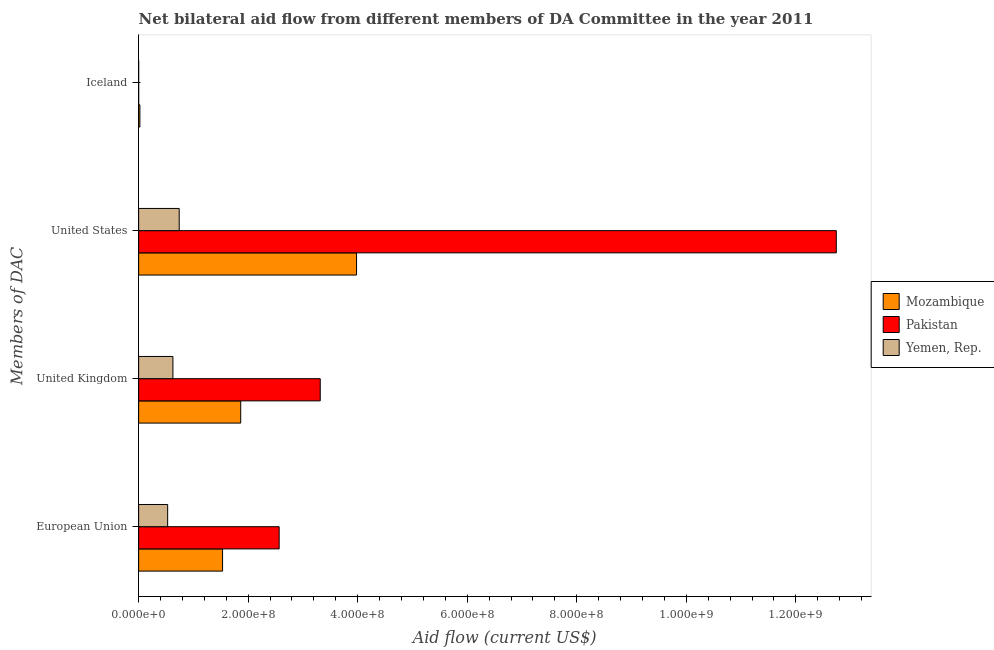Are the number of bars per tick equal to the number of legend labels?
Provide a succinct answer. Yes. What is the label of the 3rd group of bars from the top?
Offer a very short reply. United Kingdom. What is the amount of aid given by eu in Mozambique?
Your answer should be very brief. 1.53e+08. Across all countries, what is the maximum amount of aid given by us?
Offer a very short reply. 1.27e+09. Across all countries, what is the minimum amount of aid given by uk?
Make the answer very short. 6.26e+07. In which country was the amount of aid given by eu minimum?
Make the answer very short. Yemen, Rep. What is the total amount of aid given by uk in the graph?
Offer a very short reply. 5.81e+08. What is the difference between the amount of aid given by iceland in Yemen, Rep. and that in Pakistan?
Make the answer very short. -4.00e+04. What is the difference between the amount of aid given by us in Pakistan and the amount of aid given by uk in Yemen, Rep.?
Your response must be concise. 1.21e+09. What is the average amount of aid given by eu per country?
Provide a short and direct response. 1.54e+08. What is the difference between the amount of aid given by us and amount of aid given by iceland in Pakistan?
Your response must be concise. 1.27e+09. What is the ratio of the amount of aid given by uk in Pakistan to that in Mozambique?
Ensure brevity in your answer.  1.78. Is the amount of aid given by us in Yemen, Rep. less than that in Mozambique?
Offer a very short reply. Yes. Is the difference between the amount of aid given by eu in Mozambique and Yemen, Rep. greater than the difference between the amount of aid given by us in Mozambique and Yemen, Rep.?
Make the answer very short. No. What is the difference between the highest and the second highest amount of aid given by eu?
Provide a short and direct response. 1.03e+08. What is the difference between the highest and the lowest amount of aid given by uk?
Make the answer very short. 2.69e+08. Is the sum of the amount of aid given by iceland in Pakistan and Mozambique greater than the maximum amount of aid given by uk across all countries?
Ensure brevity in your answer.  No. Is it the case that in every country, the sum of the amount of aid given by iceland and amount of aid given by us is greater than the sum of amount of aid given by uk and amount of aid given by eu?
Offer a terse response. No. What does the 3rd bar from the top in Iceland represents?
Ensure brevity in your answer.  Mozambique. What does the 3rd bar from the bottom in United Kingdom represents?
Offer a very short reply. Yemen, Rep. Is it the case that in every country, the sum of the amount of aid given by eu and amount of aid given by uk is greater than the amount of aid given by us?
Give a very brief answer. No. Are all the bars in the graph horizontal?
Keep it short and to the point. Yes. How many countries are there in the graph?
Offer a very short reply. 3. What is the difference between two consecutive major ticks on the X-axis?
Your response must be concise. 2.00e+08. Are the values on the major ticks of X-axis written in scientific E-notation?
Your answer should be compact. Yes. Does the graph contain any zero values?
Offer a very short reply. No. Does the graph contain grids?
Make the answer very short. No. Where does the legend appear in the graph?
Give a very brief answer. Center right. How many legend labels are there?
Ensure brevity in your answer.  3. What is the title of the graph?
Provide a short and direct response. Net bilateral aid flow from different members of DA Committee in the year 2011. What is the label or title of the Y-axis?
Ensure brevity in your answer.  Members of DAC. What is the Aid flow (current US$) of Mozambique in European Union?
Your response must be concise. 1.53e+08. What is the Aid flow (current US$) in Pakistan in European Union?
Ensure brevity in your answer.  2.57e+08. What is the Aid flow (current US$) of Yemen, Rep. in European Union?
Your answer should be compact. 5.30e+07. What is the Aid flow (current US$) of Mozambique in United Kingdom?
Ensure brevity in your answer.  1.86e+08. What is the Aid flow (current US$) of Pakistan in United Kingdom?
Provide a succinct answer. 3.32e+08. What is the Aid flow (current US$) in Yemen, Rep. in United Kingdom?
Offer a very short reply. 6.26e+07. What is the Aid flow (current US$) in Mozambique in United States?
Give a very brief answer. 3.98e+08. What is the Aid flow (current US$) of Pakistan in United States?
Provide a short and direct response. 1.27e+09. What is the Aid flow (current US$) of Yemen, Rep. in United States?
Make the answer very short. 7.41e+07. What is the Aid flow (current US$) of Mozambique in Iceland?
Offer a very short reply. 2.29e+06. What is the Aid flow (current US$) in Yemen, Rep. in Iceland?
Make the answer very short. 2.00e+04. Across all Members of DAC, what is the maximum Aid flow (current US$) of Mozambique?
Provide a short and direct response. 3.98e+08. Across all Members of DAC, what is the maximum Aid flow (current US$) in Pakistan?
Offer a very short reply. 1.27e+09. Across all Members of DAC, what is the maximum Aid flow (current US$) of Yemen, Rep.?
Make the answer very short. 7.41e+07. Across all Members of DAC, what is the minimum Aid flow (current US$) in Mozambique?
Give a very brief answer. 2.29e+06. Across all Members of DAC, what is the minimum Aid flow (current US$) of Pakistan?
Your answer should be compact. 6.00e+04. What is the total Aid flow (current US$) of Mozambique in the graph?
Give a very brief answer. 7.40e+08. What is the total Aid flow (current US$) of Pakistan in the graph?
Make the answer very short. 1.86e+09. What is the total Aid flow (current US$) of Yemen, Rep. in the graph?
Make the answer very short. 1.90e+08. What is the difference between the Aid flow (current US$) of Mozambique in European Union and that in United Kingdom?
Give a very brief answer. -3.32e+07. What is the difference between the Aid flow (current US$) of Pakistan in European Union and that in United Kingdom?
Provide a short and direct response. -7.50e+07. What is the difference between the Aid flow (current US$) in Yemen, Rep. in European Union and that in United Kingdom?
Your answer should be very brief. -9.61e+06. What is the difference between the Aid flow (current US$) in Mozambique in European Union and that in United States?
Give a very brief answer. -2.45e+08. What is the difference between the Aid flow (current US$) of Pakistan in European Union and that in United States?
Ensure brevity in your answer.  -1.02e+09. What is the difference between the Aid flow (current US$) of Yemen, Rep. in European Union and that in United States?
Your response must be concise. -2.11e+07. What is the difference between the Aid flow (current US$) of Mozambique in European Union and that in Iceland?
Your answer should be very brief. 1.51e+08. What is the difference between the Aid flow (current US$) in Pakistan in European Union and that in Iceland?
Give a very brief answer. 2.57e+08. What is the difference between the Aid flow (current US$) of Yemen, Rep. in European Union and that in Iceland?
Your answer should be very brief. 5.30e+07. What is the difference between the Aid flow (current US$) in Mozambique in United Kingdom and that in United States?
Your response must be concise. -2.12e+08. What is the difference between the Aid flow (current US$) in Pakistan in United Kingdom and that in United States?
Give a very brief answer. -9.42e+08. What is the difference between the Aid flow (current US$) of Yemen, Rep. in United Kingdom and that in United States?
Give a very brief answer. -1.15e+07. What is the difference between the Aid flow (current US$) in Mozambique in United Kingdom and that in Iceland?
Provide a succinct answer. 1.84e+08. What is the difference between the Aid flow (current US$) of Pakistan in United Kingdom and that in Iceland?
Your answer should be compact. 3.32e+08. What is the difference between the Aid flow (current US$) in Yemen, Rep. in United Kingdom and that in Iceland?
Keep it short and to the point. 6.26e+07. What is the difference between the Aid flow (current US$) in Mozambique in United States and that in Iceland?
Keep it short and to the point. 3.96e+08. What is the difference between the Aid flow (current US$) of Pakistan in United States and that in Iceland?
Offer a very short reply. 1.27e+09. What is the difference between the Aid flow (current US$) in Yemen, Rep. in United States and that in Iceland?
Make the answer very short. 7.41e+07. What is the difference between the Aid flow (current US$) of Mozambique in European Union and the Aid flow (current US$) of Pakistan in United Kingdom?
Keep it short and to the point. -1.78e+08. What is the difference between the Aid flow (current US$) of Mozambique in European Union and the Aid flow (current US$) of Yemen, Rep. in United Kingdom?
Your answer should be very brief. 9.06e+07. What is the difference between the Aid flow (current US$) in Pakistan in European Union and the Aid flow (current US$) in Yemen, Rep. in United Kingdom?
Give a very brief answer. 1.94e+08. What is the difference between the Aid flow (current US$) in Mozambique in European Union and the Aid flow (current US$) in Pakistan in United States?
Provide a succinct answer. -1.12e+09. What is the difference between the Aid flow (current US$) of Mozambique in European Union and the Aid flow (current US$) of Yemen, Rep. in United States?
Provide a short and direct response. 7.92e+07. What is the difference between the Aid flow (current US$) of Pakistan in European Union and the Aid flow (current US$) of Yemen, Rep. in United States?
Ensure brevity in your answer.  1.83e+08. What is the difference between the Aid flow (current US$) in Mozambique in European Union and the Aid flow (current US$) in Pakistan in Iceland?
Offer a terse response. 1.53e+08. What is the difference between the Aid flow (current US$) in Mozambique in European Union and the Aid flow (current US$) in Yemen, Rep. in Iceland?
Ensure brevity in your answer.  1.53e+08. What is the difference between the Aid flow (current US$) in Pakistan in European Union and the Aid flow (current US$) in Yemen, Rep. in Iceland?
Your answer should be very brief. 2.57e+08. What is the difference between the Aid flow (current US$) of Mozambique in United Kingdom and the Aid flow (current US$) of Pakistan in United States?
Give a very brief answer. -1.09e+09. What is the difference between the Aid flow (current US$) in Mozambique in United Kingdom and the Aid flow (current US$) in Yemen, Rep. in United States?
Give a very brief answer. 1.12e+08. What is the difference between the Aid flow (current US$) of Pakistan in United Kingdom and the Aid flow (current US$) of Yemen, Rep. in United States?
Provide a succinct answer. 2.58e+08. What is the difference between the Aid flow (current US$) of Mozambique in United Kingdom and the Aid flow (current US$) of Pakistan in Iceland?
Your answer should be compact. 1.86e+08. What is the difference between the Aid flow (current US$) in Mozambique in United Kingdom and the Aid flow (current US$) in Yemen, Rep. in Iceland?
Provide a succinct answer. 1.86e+08. What is the difference between the Aid flow (current US$) of Pakistan in United Kingdom and the Aid flow (current US$) of Yemen, Rep. in Iceland?
Ensure brevity in your answer.  3.32e+08. What is the difference between the Aid flow (current US$) in Mozambique in United States and the Aid flow (current US$) in Pakistan in Iceland?
Offer a terse response. 3.98e+08. What is the difference between the Aid flow (current US$) of Mozambique in United States and the Aid flow (current US$) of Yemen, Rep. in Iceland?
Make the answer very short. 3.98e+08. What is the difference between the Aid flow (current US$) of Pakistan in United States and the Aid flow (current US$) of Yemen, Rep. in Iceland?
Your answer should be compact. 1.27e+09. What is the average Aid flow (current US$) in Mozambique per Members of DAC?
Make the answer very short. 1.85e+08. What is the average Aid flow (current US$) in Pakistan per Members of DAC?
Ensure brevity in your answer.  4.66e+08. What is the average Aid flow (current US$) of Yemen, Rep. per Members of DAC?
Keep it short and to the point. 4.74e+07. What is the difference between the Aid flow (current US$) of Mozambique and Aid flow (current US$) of Pakistan in European Union?
Ensure brevity in your answer.  -1.03e+08. What is the difference between the Aid flow (current US$) in Mozambique and Aid flow (current US$) in Yemen, Rep. in European Union?
Provide a succinct answer. 1.00e+08. What is the difference between the Aid flow (current US$) of Pakistan and Aid flow (current US$) of Yemen, Rep. in European Union?
Your response must be concise. 2.04e+08. What is the difference between the Aid flow (current US$) of Mozambique and Aid flow (current US$) of Pakistan in United Kingdom?
Give a very brief answer. -1.45e+08. What is the difference between the Aid flow (current US$) of Mozambique and Aid flow (current US$) of Yemen, Rep. in United Kingdom?
Provide a short and direct response. 1.24e+08. What is the difference between the Aid flow (current US$) of Pakistan and Aid flow (current US$) of Yemen, Rep. in United Kingdom?
Your response must be concise. 2.69e+08. What is the difference between the Aid flow (current US$) in Mozambique and Aid flow (current US$) in Pakistan in United States?
Your answer should be very brief. -8.76e+08. What is the difference between the Aid flow (current US$) of Mozambique and Aid flow (current US$) of Yemen, Rep. in United States?
Give a very brief answer. 3.24e+08. What is the difference between the Aid flow (current US$) in Pakistan and Aid flow (current US$) in Yemen, Rep. in United States?
Give a very brief answer. 1.20e+09. What is the difference between the Aid flow (current US$) in Mozambique and Aid flow (current US$) in Pakistan in Iceland?
Give a very brief answer. 2.23e+06. What is the difference between the Aid flow (current US$) in Mozambique and Aid flow (current US$) in Yemen, Rep. in Iceland?
Your answer should be very brief. 2.27e+06. What is the difference between the Aid flow (current US$) of Pakistan and Aid flow (current US$) of Yemen, Rep. in Iceland?
Your response must be concise. 4.00e+04. What is the ratio of the Aid flow (current US$) in Mozambique in European Union to that in United Kingdom?
Your response must be concise. 0.82. What is the ratio of the Aid flow (current US$) in Pakistan in European Union to that in United Kingdom?
Provide a short and direct response. 0.77. What is the ratio of the Aid flow (current US$) of Yemen, Rep. in European Union to that in United Kingdom?
Make the answer very short. 0.85. What is the ratio of the Aid flow (current US$) of Mozambique in European Union to that in United States?
Offer a terse response. 0.39. What is the ratio of the Aid flow (current US$) of Pakistan in European Union to that in United States?
Offer a terse response. 0.2. What is the ratio of the Aid flow (current US$) of Yemen, Rep. in European Union to that in United States?
Keep it short and to the point. 0.72. What is the ratio of the Aid flow (current US$) of Mozambique in European Union to that in Iceland?
Provide a succinct answer. 66.92. What is the ratio of the Aid flow (current US$) in Pakistan in European Union to that in Iceland?
Provide a short and direct response. 4276.5. What is the ratio of the Aid flow (current US$) in Yemen, Rep. in European Union to that in Iceland?
Provide a succinct answer. 2650. What is the ratio of the Aid flow (current US$) in Mozambique in United Kingdom to that in United States?
Your answer should be very brief. 0.47. What is the ratio of the Aid flow (current US$) in Pakistan in United Kingdom to that in United States?
Make the answer very short. 0.26. What is the ratio of the Aid flow (current US$) in Yemen, Rep. in United Kingdom to that in United States?
Make the answer very short. 0.85. What is the ratio of the Aid flow (current US$) in Mozambique in United Kingdom to that in Iceland?
Ensure brevity in your answer.  81.4. What is the ratio of the Aid flow (current US$) of Pakistan in United Kingdom to that in Iceland?
Make the answer very short. 5526.5. What is the ratio of the Aid flow (current US$) in Yemen, Rep. in United Kingdom to that in Iceland?
Keep it short and to the point. 3130.5. What is the ratio of the Aid flow (current US$) in Mozambique in United States to that in Iceland?
Your response must be concise. 173.76. What is the ratio of the Aid flow (current US$) of Pakistan in United States to that in Iceland?
Ensure brevity in your answer.  2.12e+04. What is the ratio of the Aid flow (current US$) of Yemen, Rep. in United States to that in Iceland?
Provide a short and direct response. 3704. What is the difference between the highest and the second highest Aid flow (current US$) in Mozambique?
Provide a succinct answer. 2.12e+08. What is the difference between the highest and the second highest Aid flow (current US$) of Pakistan?
Offer a very short reply. 9.42e+08. What is the difference between the highest and the second highest Aid flow (current US$) of Yemen, Rep.?
Your response must be concise. 1.15e+07. What is the difference between the highest and the lowest Aid flow (current US$) in Mozambique?
Keep it short and to the point. 3.96e+08. What is the difference between the highest and the lowest Aid flow (current US$) of Pakistan?
Offer a terse response. 1.27e+09. What is the difference between the highest and the lowest Aid flow (current US$) in Yemen, Rep.?
Offer a very short reply. 7.41e+07. 